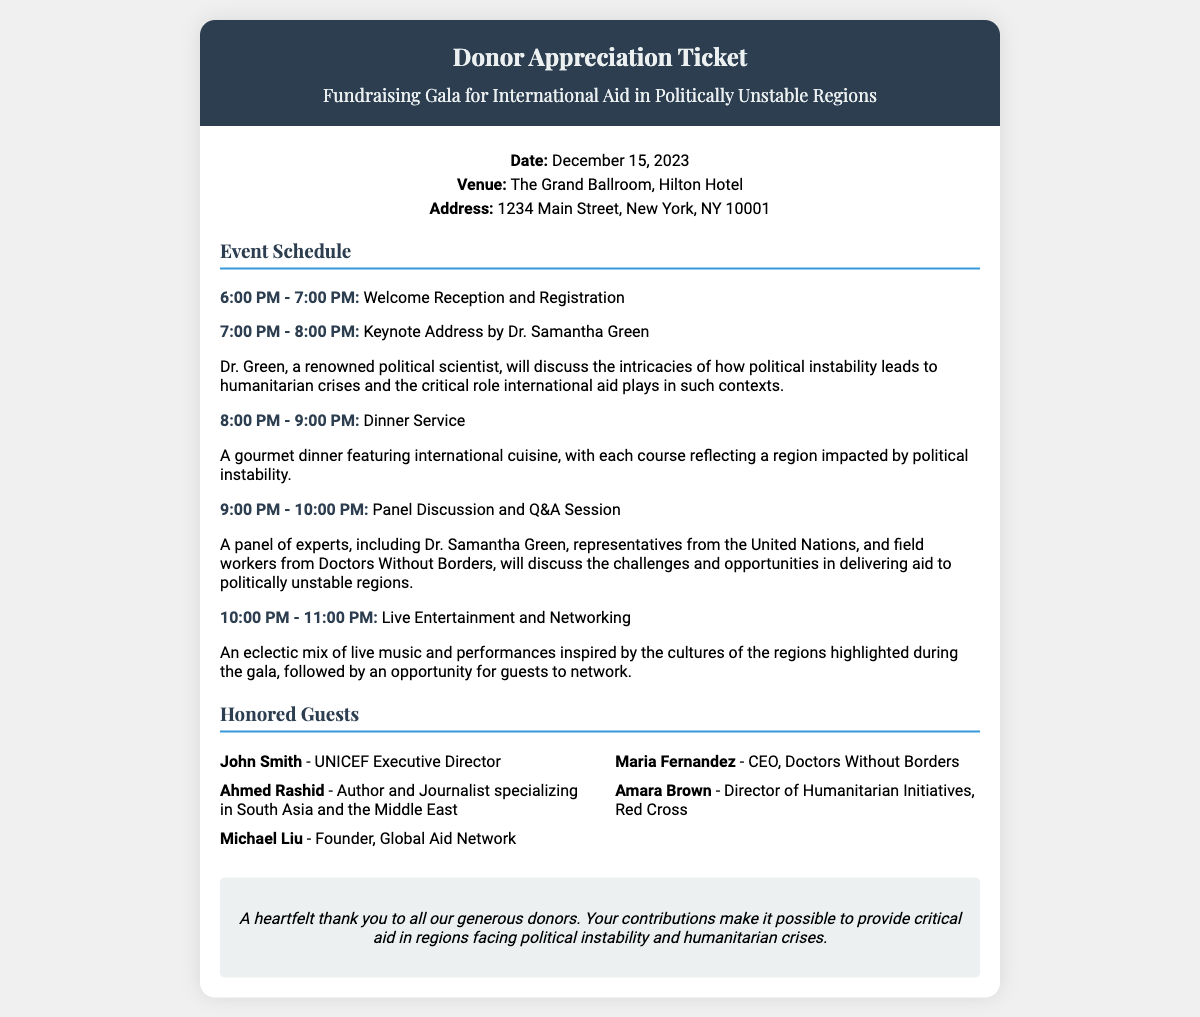What is the date of the event? The date of the event is specified in the document, which is December 15, 2023.
Answer: December 15, 2023 Where is the gala being held? The venue for the gala is listed in the document as The Grand Ballroom, Hilton Hotel.
Answer: The Grand Ballroom, Hilton Hotel Who is the keynote speaker? The document states that Dr. Samantha Green will deliver the keynote address.
Answer: Dr. Samantha Green What time does the welcome reception start? The welcome reception start time is detailed in the event schedule as 6:00 PM.
Answer: 6:00 PM Which organization does Maria Fernandez lead? According to the guest list, Maria Fernandez is the CEO of Doctors Without Borders.
Answer: Doctors Without Borders What type of cuisine will be served during dinner? The document mentions that the dinner will feature international cuisine.
Answer: International cuisine What is the purpose of the gala? The purpose of the gala is to support international aid in politically unstable regions.
Answer: International aid in politically unstable regions Who is thanked for their contributions at the event? The special thanks section expresses gratitude toward the generous donors.
Answer: Generous donors 